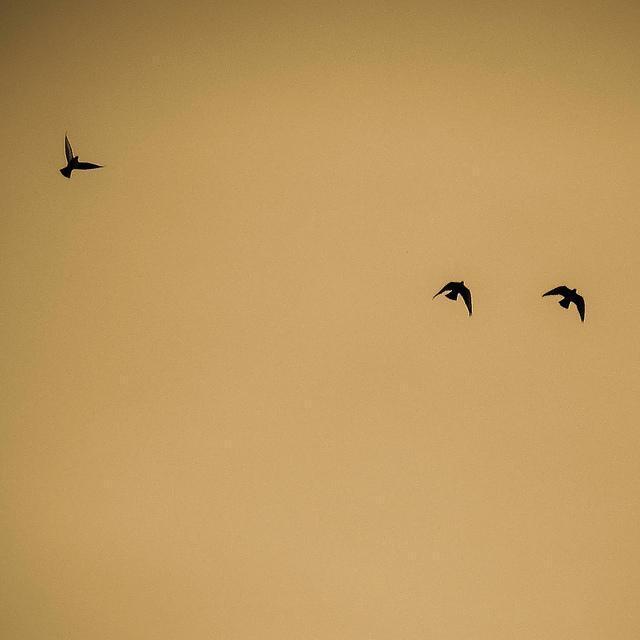How many birds are there?
Give a very brief answer. 3. How many wings are there?
Give a very brief answer. 6. How many birds are flying?
Give a very brief answer. 3. How many birds?
Give a very brief answer. 3. How many people are in the boats?
Give a very brief answer. 0. 